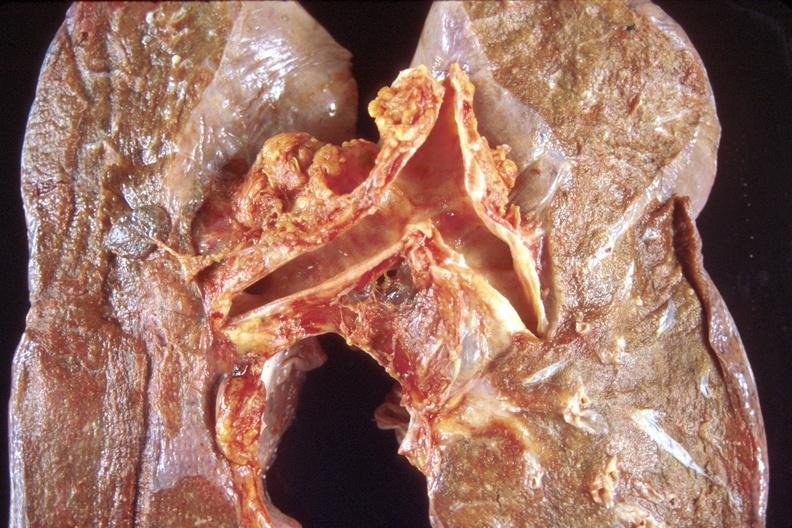s respiratory present?
Answer the question using a single word or phrase. Yes 